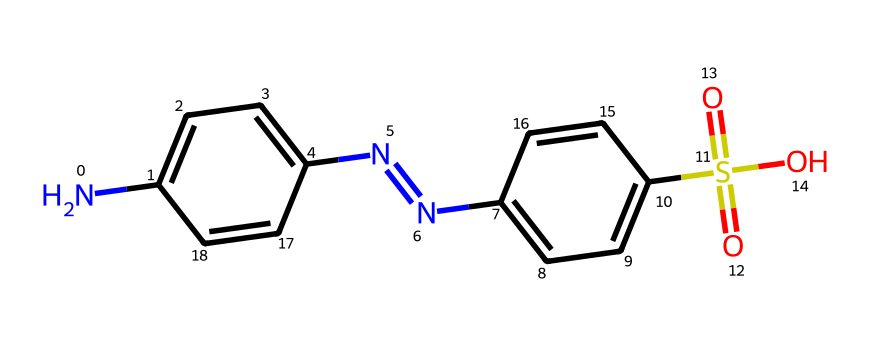What is the total number of nitrogen atoms in this structure? By analyzing the SMILES representation, we see that there are two distinct nitrogen atoms present within the molecular structure, indicated by the "N" symbols.
Answer: two How many rings are present in the compound? The SMILES indicates two benzene rings, evident from the c1ccc and c2ccc parts of the structure. Each "c" represents a carbon in a ring, suggesting the presence of two rings connected through azole bonds.
Answer: two What is the functional group represented by S(=O)(=O)? The S(=O)(=O) notation indicates that there is a sulfonic acid group (-SO3H) present in this compound, characterized by sulfur bonded to three oxygen atoms, two with double bonds and one with a single bond to a hydrogen atom.
Answer: sulfonic acid What type of dye does this structure most likely represent? This compound is a diazo dye, as indicated by the presence of the -N=N- (azo linkage) between the two aromatic systems, which is typical for synthetic dyes used in the fashion industry.
Answer: diazo dye How many aromatic systems are present in this chemical? The structure contains two aromatic systems; these are the two benzene rings indicated by the 'c' designation in the SMILES. Each ring contributes to the overall color properties of the dye.
Answer: two What is the average degree of substitution for this dye? Since the two benzene rings are substituted by amine and sulfonic acid groups, and considering only the amine substitutions, the average substitution is determined to be 2 due to the presence of the two functional groups. Ideal separation leads to calculations suggesting that there are multiple substitution points.
Answer: two 